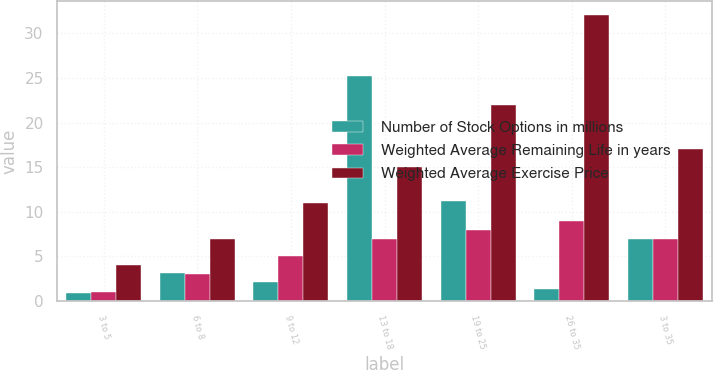<chart> <loc_0><loc_0><loc_500><loc_500><stacked_bar_chart><ecel><fcel>3 to 5<fcel>6 to 8<fcel>9 to 12<fcel>13 to 18<fcel>19 to 25<fcel>26 to 35<fcel>3 to 35<nl><fcel>Number of Stock Options in millions<fcel>0.9<fcel>3.1<fcel>2.1<fcel>25.2<fcel>11.2<fcel>1.4<fcel>7<nl><fcel>Weighted Average Remaining Life in years<fcel>1<fcel>3<fcel>5<fcel>7<fcel>8<fcel>9<fcel>7<nl><fcel>Weighted Average Exercise Price<fcel>4<fcel>7<fcel>11<fcel>15<fcel>22<fcel>32<fcel>17<nl></chart> 